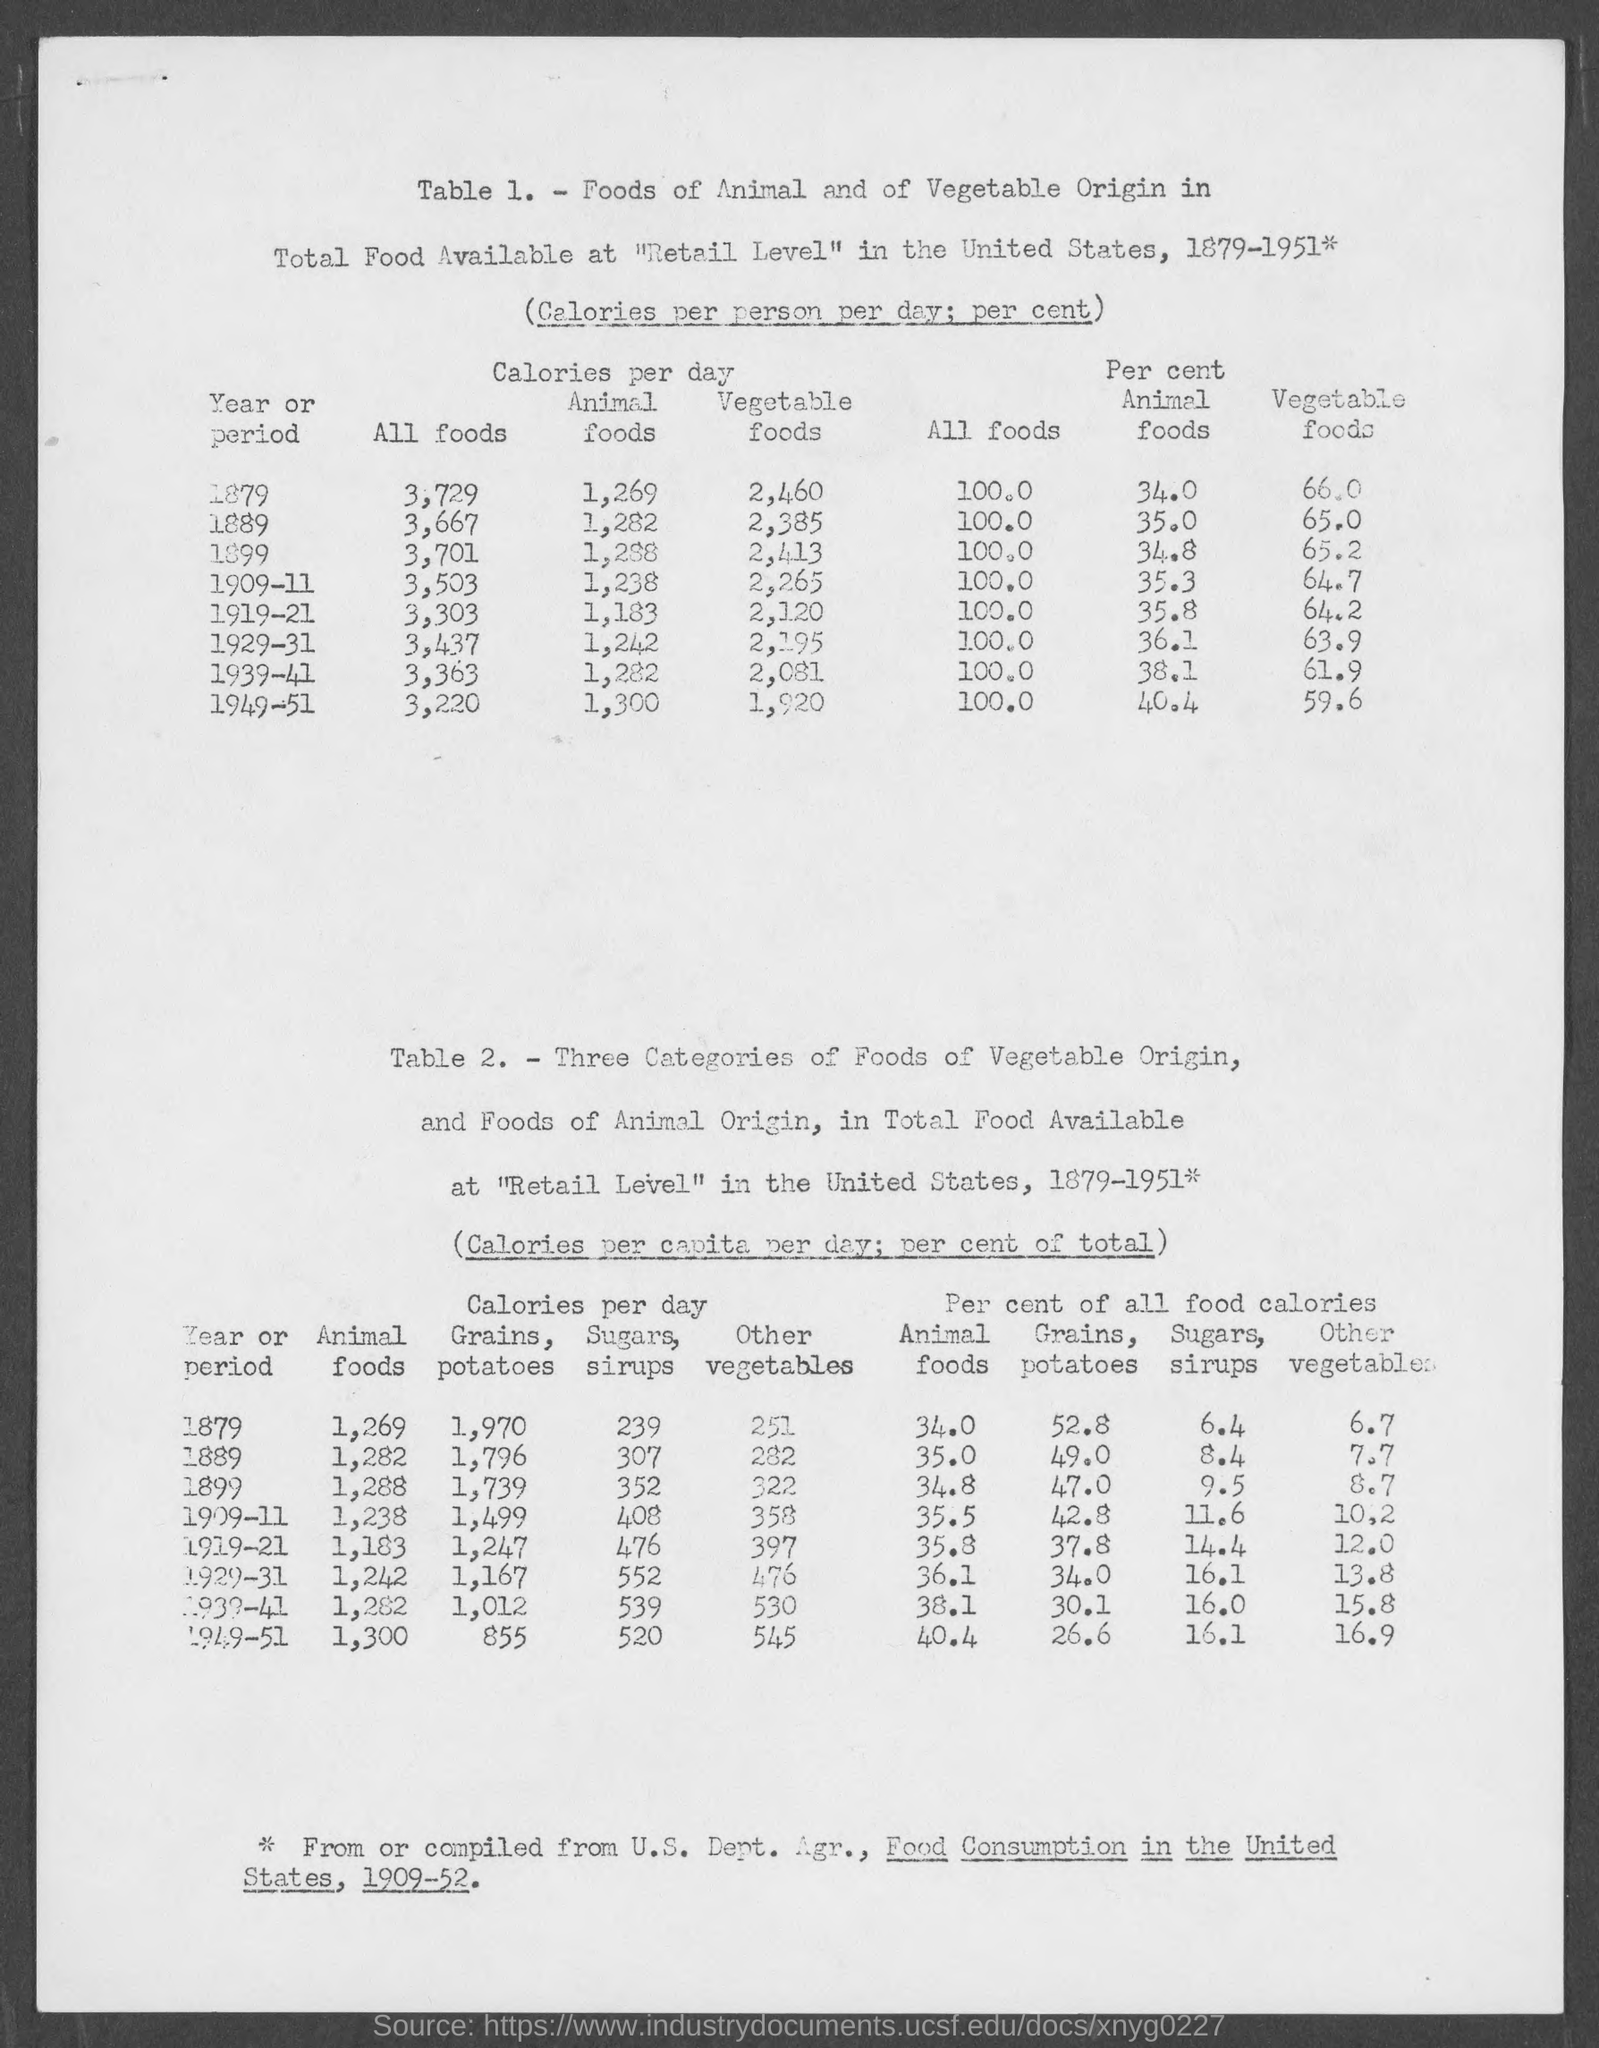What is the amount of calories per day present in all foods in the year 1879?
Provide a succinct answer. 3,729. What is the amount of calories per day present in animal foods in the year 1879?
Offer a terse response. 1,269. What is the amount of calories per day present in vegetable foods in the year 1879?
Your response must be concise. 2,460. What is the amount of calories per cent  present in all foods in the year 1879?
Ensure brevity in your answer.  100.0. What is the amount of calories per cent  present in animal foods in the year 1879?
Offer a very short reply. 34.0. What is the amount of calories per cent  present in vegetable foods in the year 1879?
Ensure brevity in your answer.  66.0. What is the amount of calories per day present in animal foods in the year 1889?
Offer a very short reply. 1,282. What is the amount of calories per day present in all foods in the year 1889?
Your answer should be compact. 3,667. What is the amount of calories per day present in vegetable foods in the year 1889?
Give a very brief answer. 2,385. What is the amount of calories per cent present in animal foods in the year 1889?
Offer a terse response. 35.0. 